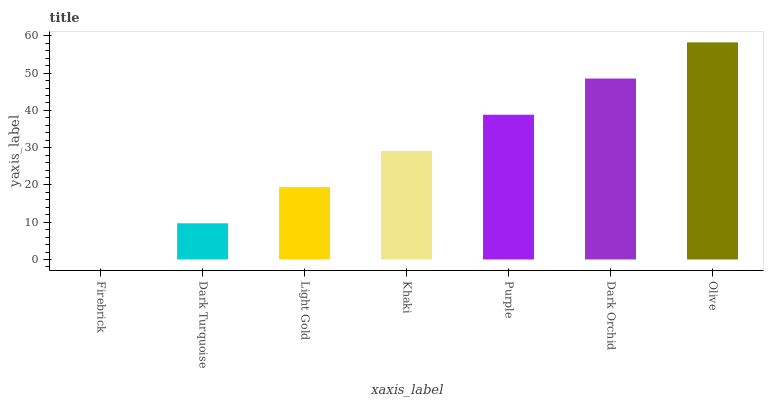Is Firebrick the minimum?
Answer yes or no. Yes. Is Olive the maximum?
Answer yes or no. Yes. Is Dark Turquoise the minimum?
Answer yes or no. No. Is Dark Turquoise the maximum?
Answer yes or no. No. Is Dark Turquoise greater than Firebrick?
Answer yes or no. Yes. Is Firebrick less than Dark Turquoise?
Answer yes or no. Yes. Is Firebrick greater than Dark Turquoise?
Answer yes or no. No. Is Dark Turquoise less than Firebrick?
Answer yes or no. No. Is Khaki the high median?
Answer yes or no. Yes. Is Khaki the low median?
Answer yes or no. Yes. Is Firebrick the high median?
Answer yes or no. No. Is Olive the low median?
Answer yes or no. No. 